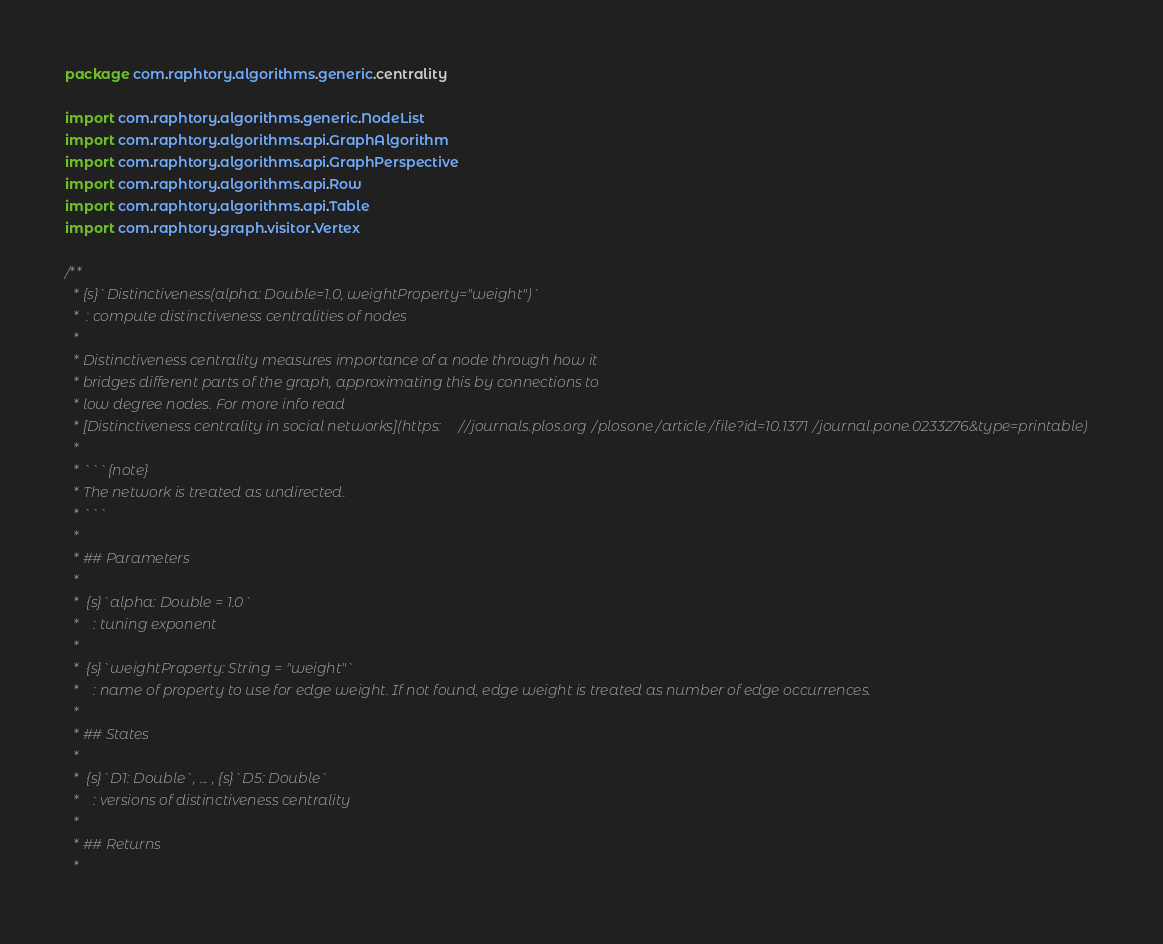Convert code to text. <code><loc_0><loc_0><loc_500><loc_500><_Scala_>package com.raphtory.algorithms.generic.centrality

import com.raphtory.algorithms.generic.NodeList
import com.raphtory.algorithms.api.GraphAlgorithm
import com.raphtory.algorithms.api.GraphPerspective
import com.raphtory.algorithms.api.Row
import com.raphtory.algorithms.api.Table
import com.raphtory.graph.visitor.Vertex

/**
  * {s}`Distinctiveness(alpha: Double=1.0, weightProperty="weight")`
  *  : compute distinctiveness centralities of nodes
  *
  * Distinctiveness centrality measures importance of a node through how it
  * bridges different parts of the graph, approximating this by connections to
  * low degree nodes. For more info read
  * [Distinctiveness centrality in social networks](https://journals.plos.org/plosone/article/file?id=10.1371/journal.pone.0233276&type=printable)
  *
  * ```{note}
  * The network is treated as undirected.
  * ```
  *
  * ## Parameters
  *
  *  {s}`alpha: Double = 1.0`
  *    : tuning exponent
  *
  *  {s}`weightProperty: String = "weight"`
  *    : name of property to use for edge weight. If not found, edge weight is treated as number of edge occurrences.
  *
  * ## States
  *
  *  {s}`D1: Double`, ... , {s}`D5: Double`
  *    : versions of distinctiveness centrality
  *
  * ## Returns
  *</code> 